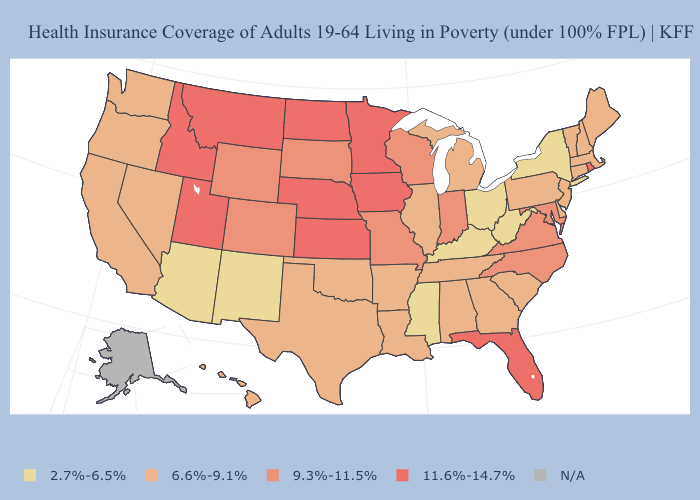Among the states that border Nebraska , does Kansas have the lowest value?
Keep it brief. No. Which states hav the highest value in the South?
Write a very short answer. Florida. Does the map have missing data?
Write a very short answer. Yes. What is the value of North Carolina?
Be succinct. 9.3%-11.5%. What is the value of Missouri?
Answer briefly. 9.3%-11.5%. Name the states that have a value in the range 6.6%-9.1%?
Short answer required. Alabama, Arkansas, California, Connecticut, Delaware, Georgia, Hawaii, Illinois, Louisiana, Maine, Massachusetts, Michigan, Nevada, New Hampshire, New Jersey, Oklahoma, Oregon, Pennsylvania, South Carolina, Tennessee, Texas, Vermont, Washington. What is the value of Idaho?
Keep it brief. 11.6%-14.7%. Does the map have missing data?
Be succinct. Yes. Among the states that border Massachusetts , does Connecticut have the highest value?
Quick response, please. No. Which states have the lowest value in the Northeast?
Give a very brief answer. New York. What is the lowest value in states that border Pennsylvania?
Answer briefly. 2.7%-6.5%. What is the highest value in states that border New Hampshire?
Quick response, please. 6.6%-9.1%. What is the highest value in the USA?
Keep it brief. 11.6%-14.7%. Name the states that have a value in the range 11.6%-14.7%?
Give a very brief answer. Florida, Idaho, Iowa, Kansas, Minnesota, Montana, Nebraska, North Dakota, Rhode Island, Utah. 